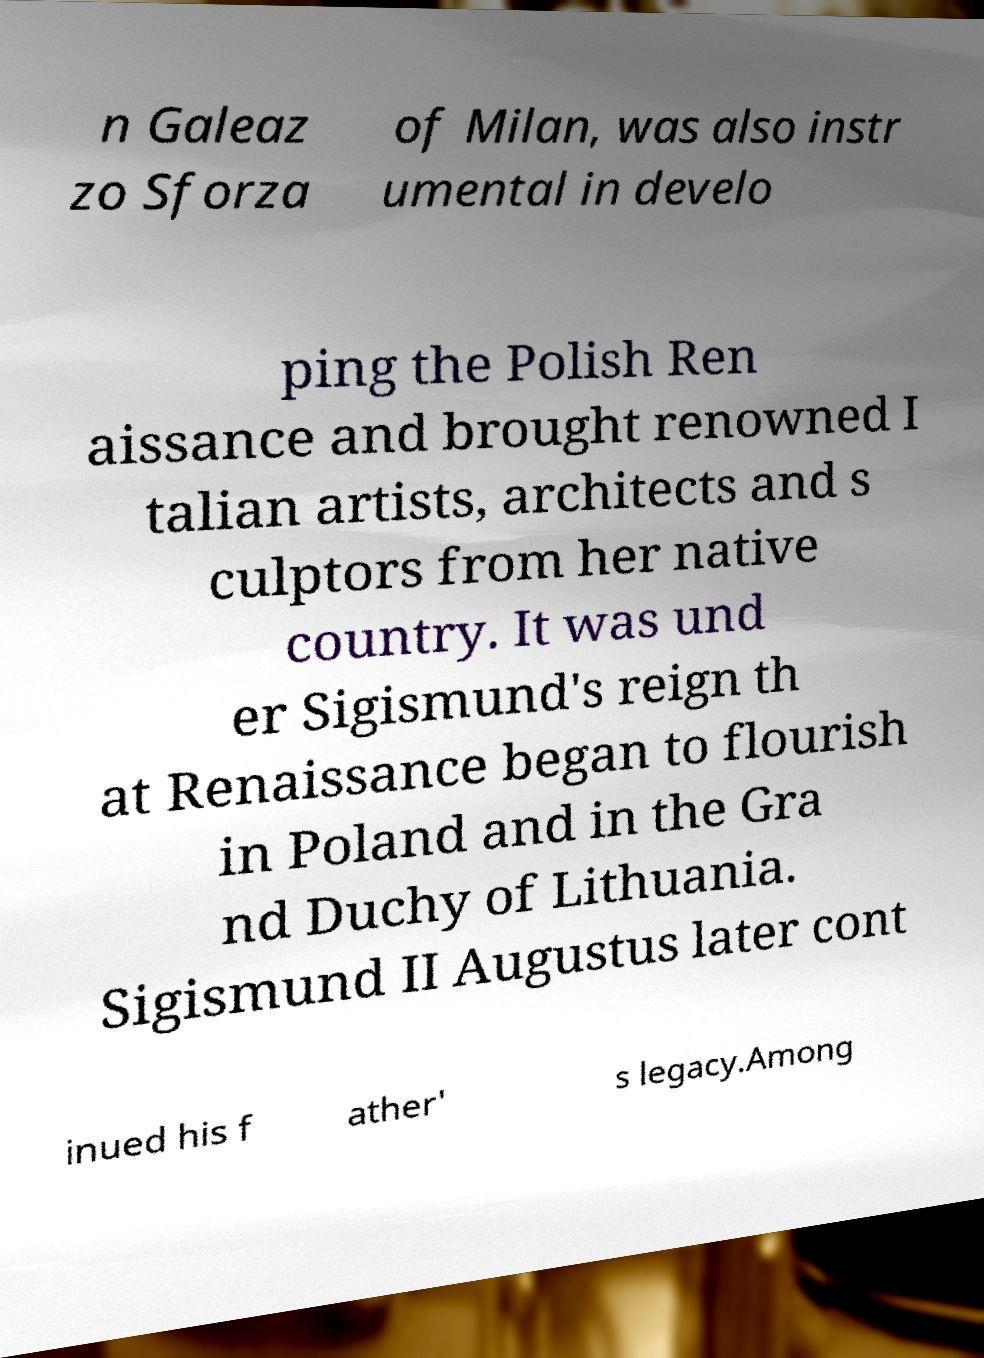What messages or text are displayed in this image? I need them in a readable, typed format. n Galeaz zo Sforza of Milan, was also instr umental in develo ping the Polish Ren aissance and brought renowned I talian artists, architects and s culptors from her native country. It was und er Sigismund's reign th at Renaissance began to flourish in Poland and in the Gra nd Duchy of Lithuania. Sigismund II Augustus later cont inued his f ather' s legacy.Among 